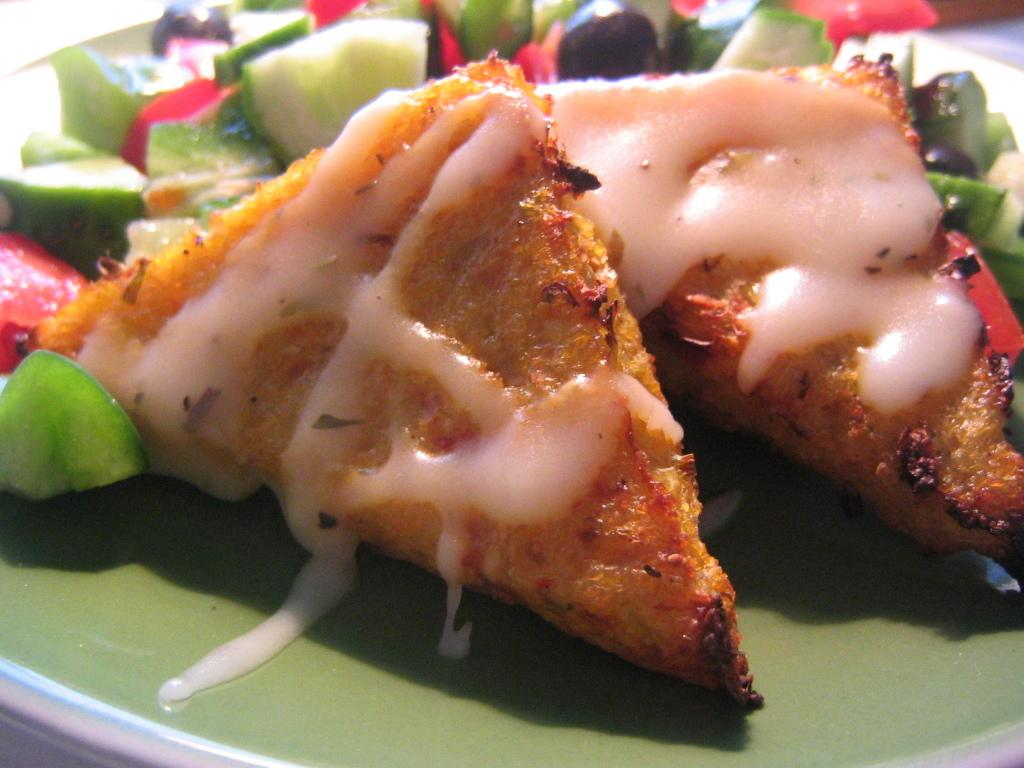What is on the plate in the image? There is food on a plate in the image. What type of cough can be heard in the image? There is no sound or audio in the image, so it is not possible to determine if a cough can be heard. 